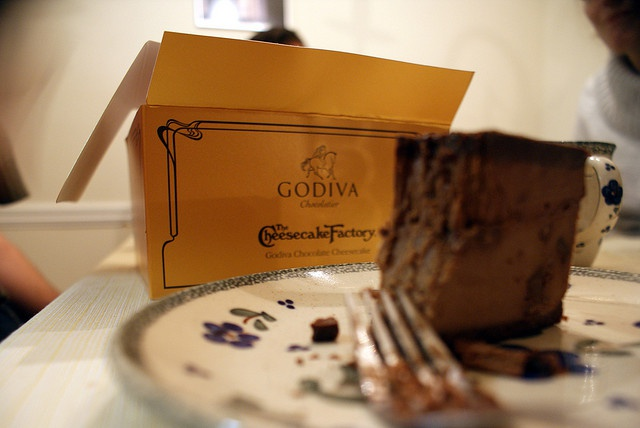Describe the objects in this image and their specific colors. I can see dining table in black, tan, and maroon tones, cake in black, maroon, and brown tones, fork in black, maroon, and gray tones, people in black, darkgray, gray, and maroon tones, and cup in black and olive tones in this image. 